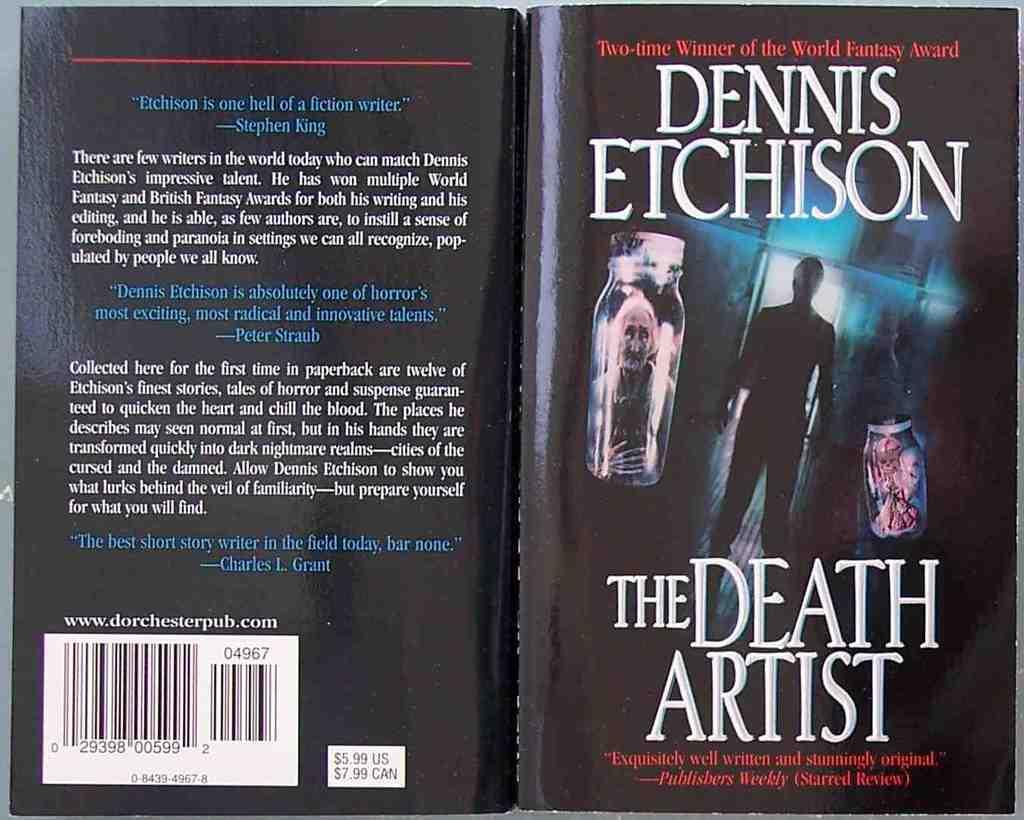What is the title of this book?
Your response must be concise. The death artist. Who is the author of this book? his name is printed in white at the top of the page on the right?
Ensure brevity in your answer.  Dennis etchison. 